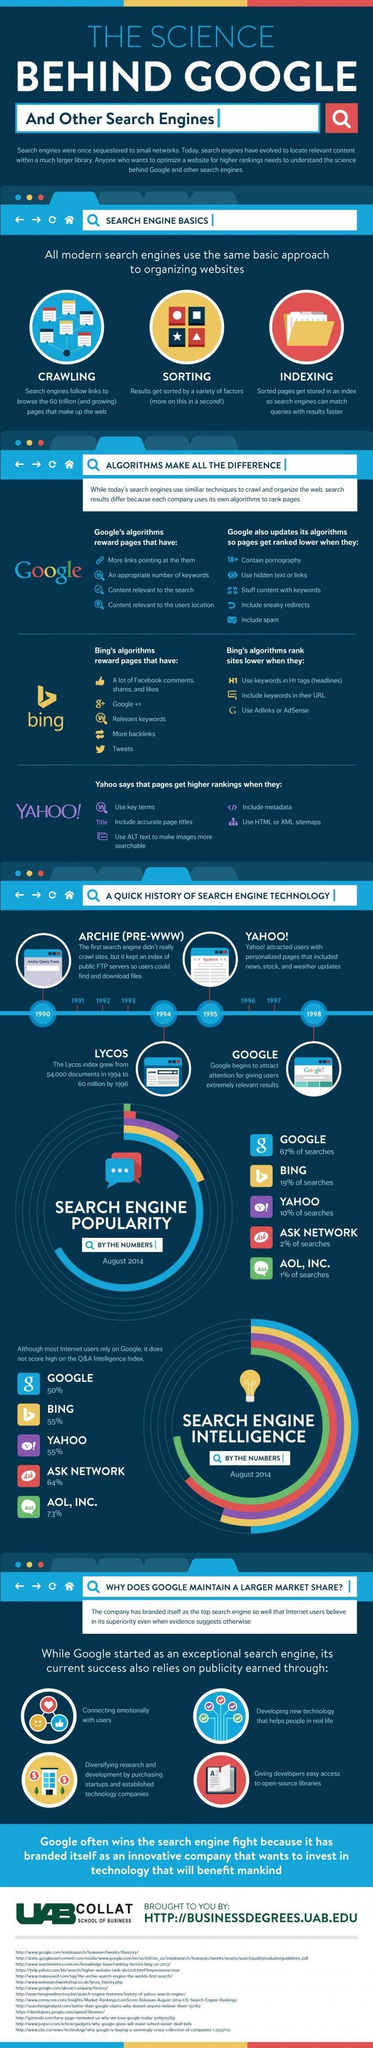What are the three basic approaches for organizing a network?
Answer the question with a short phrase. Crawling, Sorting, Indexing Which all search engines have the same Q &A  intelligence index? Bing, Yahoo What are the names of the search technologies before 1995? Archie(PRE-WWW), Lycos How many search engine technologies before 1995? 2 Which search engine has the second-highest search engine popularity? Bing How many search engines have less than 10% search engine popularity? 2 Which search engine has the highest Q &A  intelligence index? Aol, Inc. How many search engines have the same Q & A intelligence index? 2 How many approaches for organizing a network mentioned in this infographic? 3 